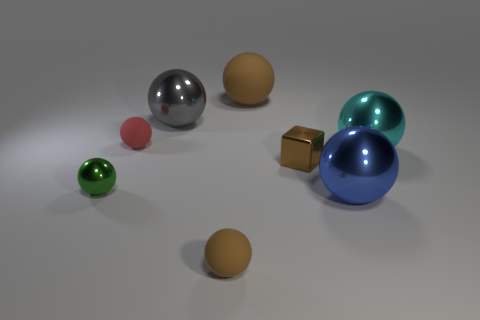Subtract all red spheres. How many spheres are left? 6 Subtract all tiny matte spheres. How many spheres are left? 5 Subtract all green balls. Subtract all green cubes. How many balls are left? 6 Add 1 big shiny spheres. How many objects exist? 9 Subtract all spheres. How many objects are left? 1 Add 7 small green metallic objects. How many small green metallic objects exist? 8 Subtract 0 red blocks. How many objects are left? 8 Subtract all large blue shiny spheres. Subtract all red matte things. How many objects are left? 6 Add 6 big spheres. How many big spheres are left? 10 